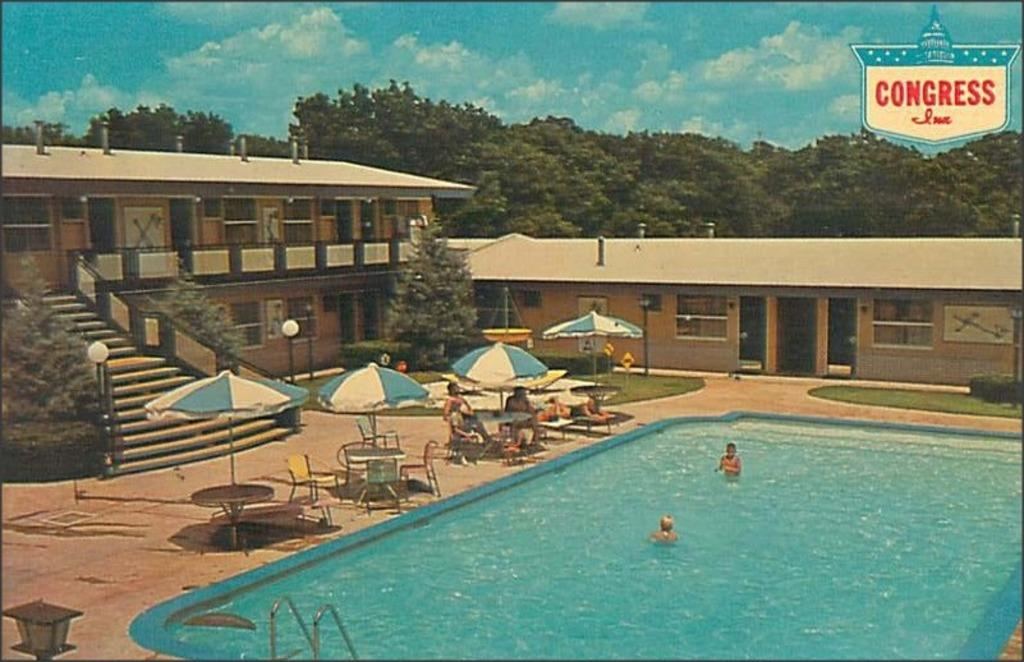What type of structure is visible in the image? There is a building in the image. What architectural feature can be seen in the building? There are staircases in the image. What type of vegetation is present in the image? There are trees in the image. What are the people in the image using to protect themselves from the weather? There are people under umbrellas in the image. Can you describe the recreational activity taking place in the image? There are two people in a swimming pool in the image. What type of clam can be seen crawling on the staircase in the image? There are no clams present in the image, and therefore no such activity can be observed. Can you tell me how many rabbits are hiding under the trees in the image? There are no rabbits present in the image; only trees and people under umbrellas can be seen. 